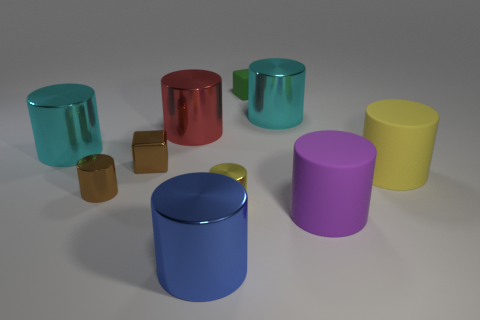Are there the same number of brown cylinders that are to the right of the red metallic cylinder and small green rubber blocks that are behind the small green object? Indeed, upon careful examination of the image, it appears that the quantity of brown cylinders positioned to the right of the red metallic cylinder does match the number of small green rubber blocks situated behind the green object, thus maintaining a balance in the visual composition. 